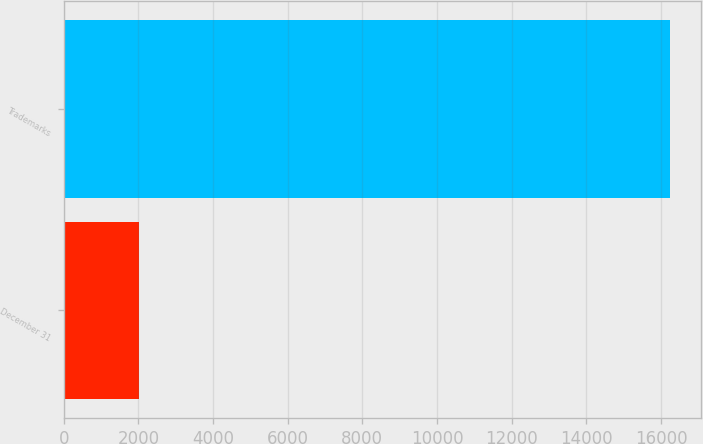<chart> <loc_0><loc_0><loc_500><loc_500><bar_chart><fcel>December 31<fcel>Trademarks<nl><fcel>2015<fcel>16246<nl></chart> 